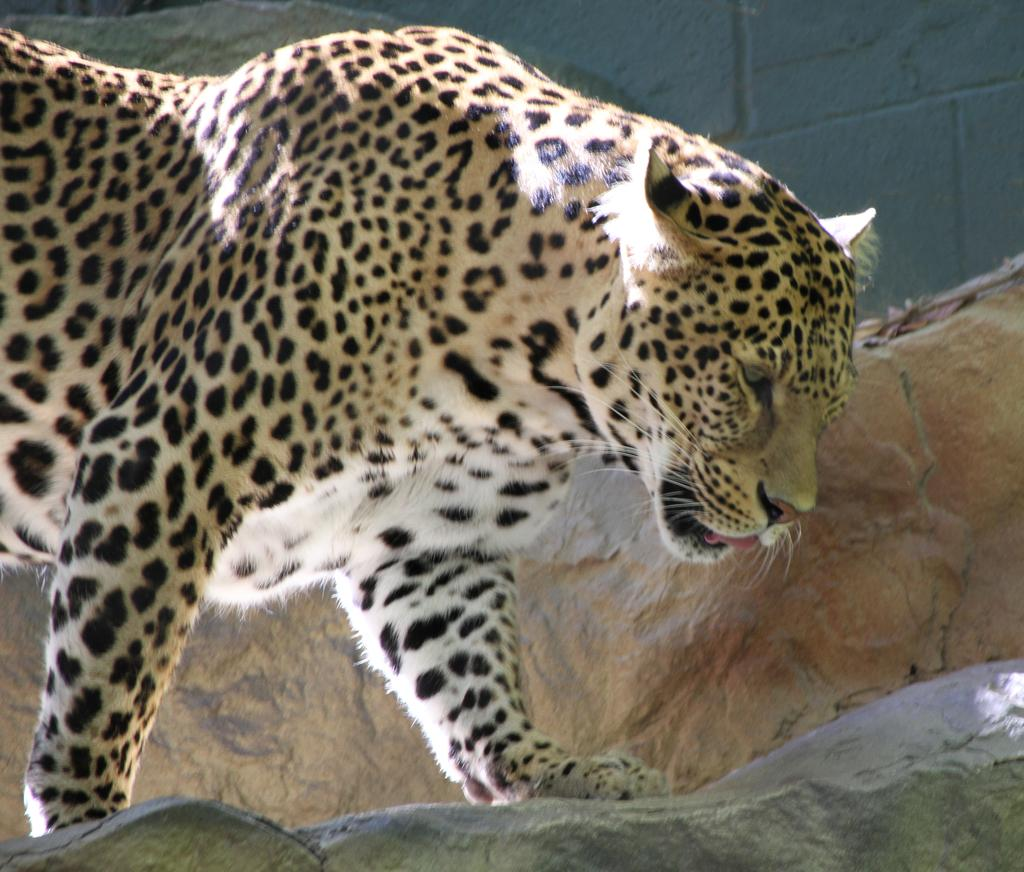What animal is the main subject of the image? There is a cheetah in the image. What is the cheetah doing in the image? The cheetah is walking on rocks. What type of nail polish is the cheetah wearing in the image? The cheetah is not wearing nail polish in the image, as it is an animal and does not use cosmetics. 